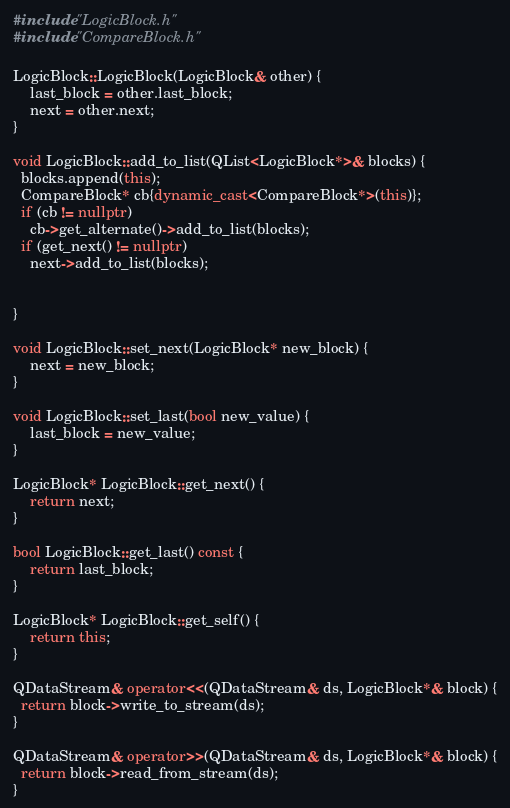<code> <loc_0><loc_0><loc_500><loc_500><_C++_>#include "LogicBlock.h"
#include "CompareBlock.h"

LogicBlock::LogicBlock(LogicBlock& other) {
    last_block = other.last_block;
    next = other.next;
}

void LogicBlock::add_to_list(QList<LogicBlock*>& blocks) {
  blocks.append(this);
  CompareBlock* cb{dynamic_cast<CompareBlock*>(this)};
  if (cb != nullptr)
    cb->get_alternate()->add_to_list(blocks);
  if (get_next() != nullptr)
    next->add_to_list(blocks);


}

void LogicBlock::set_next(LogicBlock* new_block) {
    next = new_block;
}

void LogicBlock::set_last(bool new_value) {
    last_block = new_value;
}

LogicBlock* LogicBlock::get_next() {
    return next;
}

bool LogicBlock::get_last() const {
    return last_block;
}

LogicBlock* LogicBlock::get_self() {
    return this;
}

QDataStream& operator<<(QDataStream& ds, LogicBlock*& block) {
  return block->write_to_stream(ds);
}

QDataStream& operator>>(QDataStream& ds, LogicBlock*& block) {
  return block->read_from_stream(ds);
}

</code> 